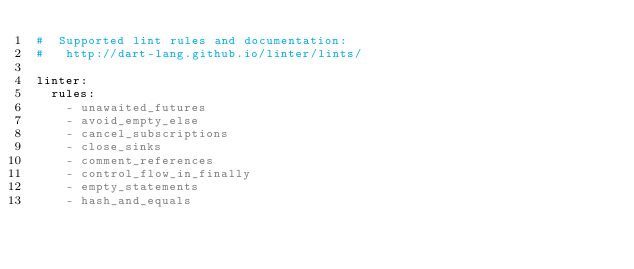Convert code to text. <code><loc_0><loc_0><loc_500><loc_500><_YAML_>#  Supported lint rules and documentation:
#   http://dart-lang.github.io/linter/lints/

linter:
  rules:
    - unawaited_futures
    - avoid_empty_else
    - cancel_subscriptions
    - close_sinks
    - comment_references
    - control_flow_in_finally
    - empty_statements
    - hash_and_equals</code> 